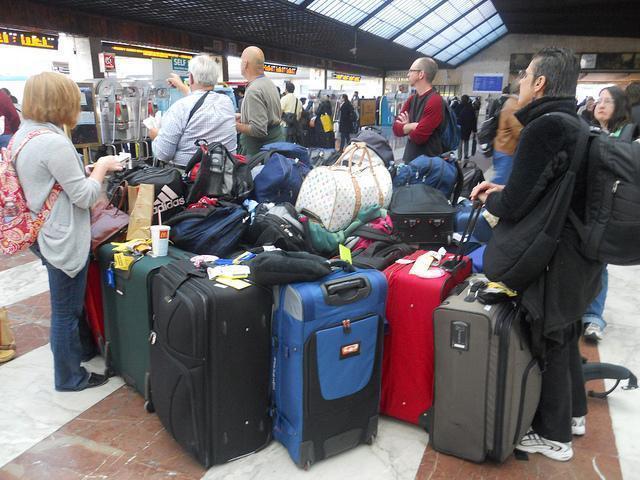What activity are these people engaged in?
Answer the question by selecting the correct answer among the 4 following choices and explain your choice with a short sentence. The answer should be formatted with the following format: `Answer: choice
Rationale: rationale.`
Options: Sport, travel, debate, celebration. Answer: travel.
Rationale: They have a large amount of luggage with them signifying they are taking a trip together. 